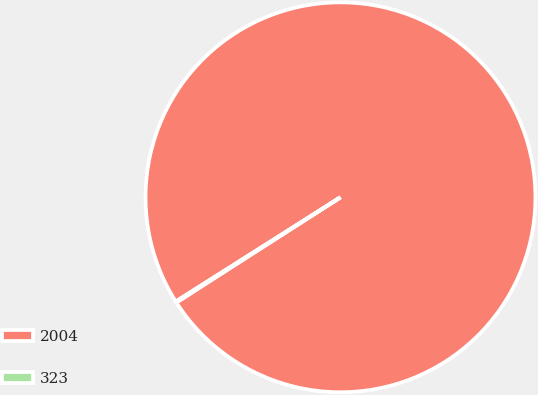Convert chart. <chart><loc_0><loc_0><loc_500><loc_500><pie_chart><fcel>2004<fcel>323<nl><fcel>99.9%<fcel>0.1%<nl></chart> 